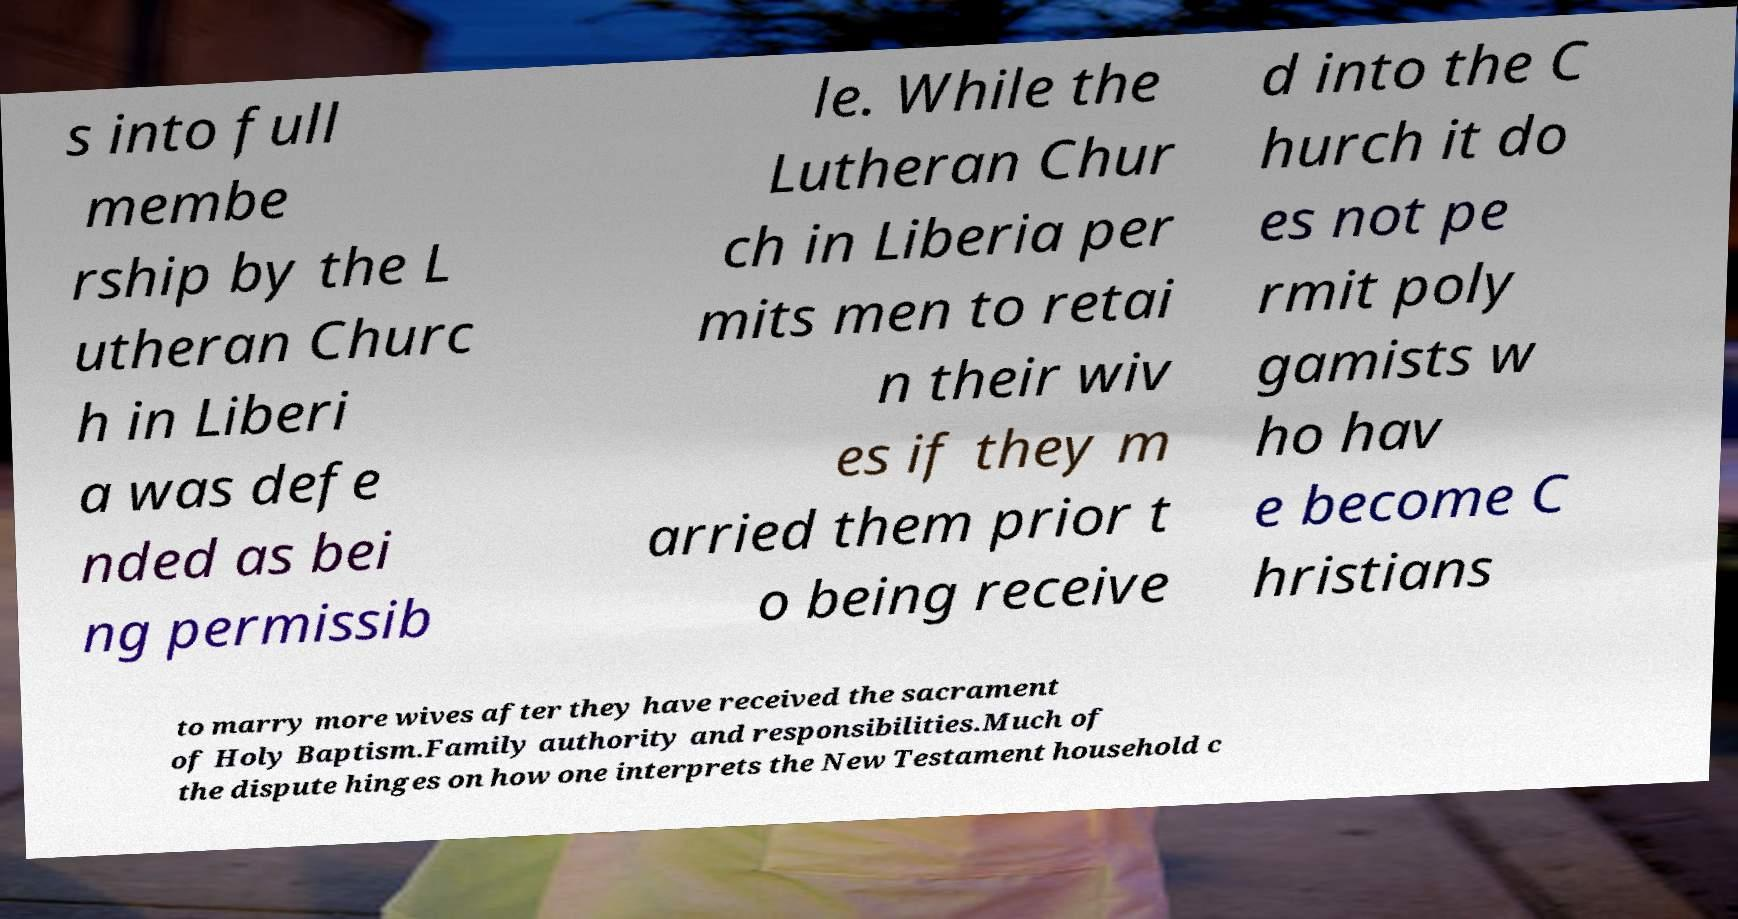Please identify and transcribe the text found in this image. s into full membe rship by the L utheran Churc h in Liberi a was defe nded as bei ng permissib le. While the Lutheran Chur ch in Liberia per mits men to retai n their wiv es if they m arried them prior t o being receive d into the C hurch it do es not pe rmit poly gamists w ho hav e become C hristians to marry more wives after they have received the sacrament of Holy Baptism.Family authority and responsibilities.Much of the dispute hinges on how one interprets the New Testament household c 